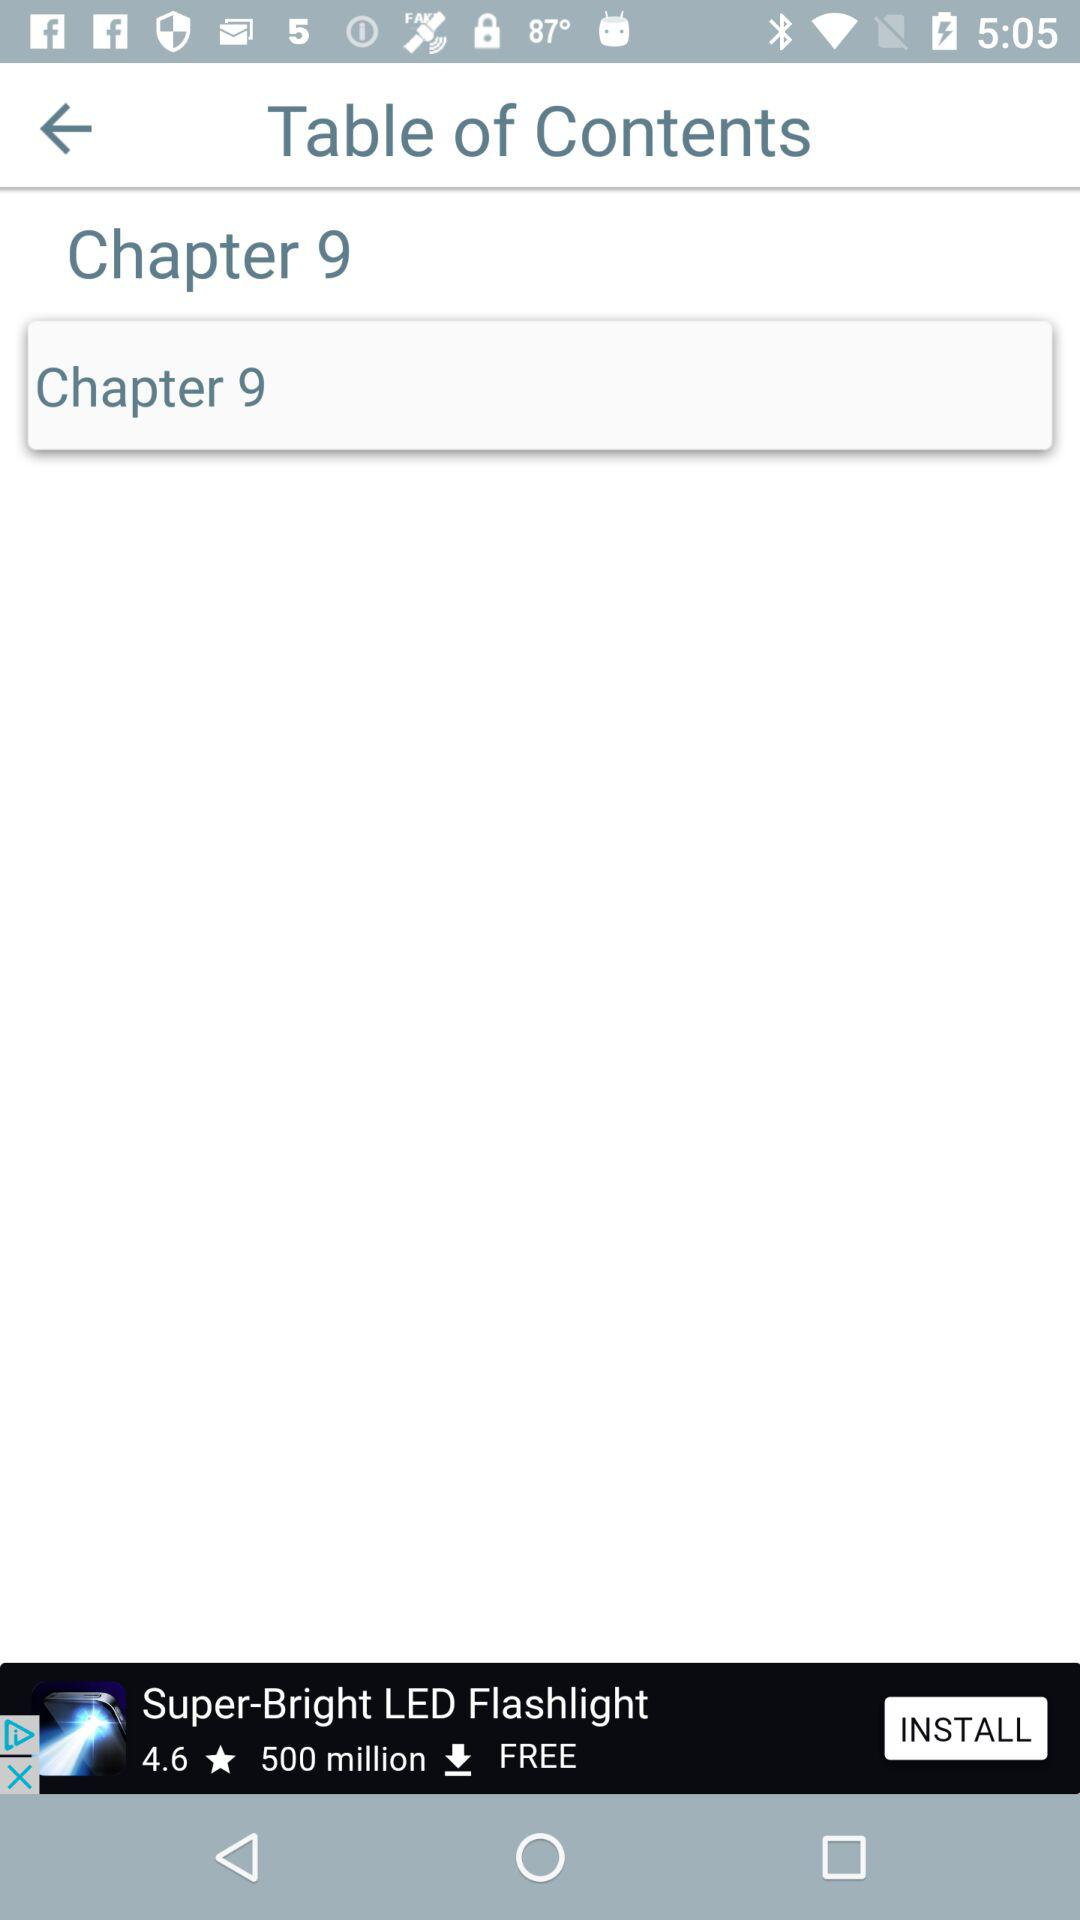Which chapter does the table of contents contain? The table of contents contains 9th chapter. 